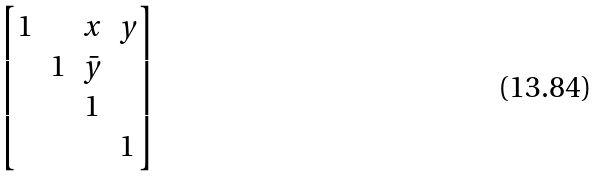<formula> <loc_0><loc_0><loc_500><loc_500>\begin{bmatrix} 1 & & x & y \\ & 1 & \bar { y } \\ & & 1 \\ & & & 1 \end{bmatrix}</formula> 